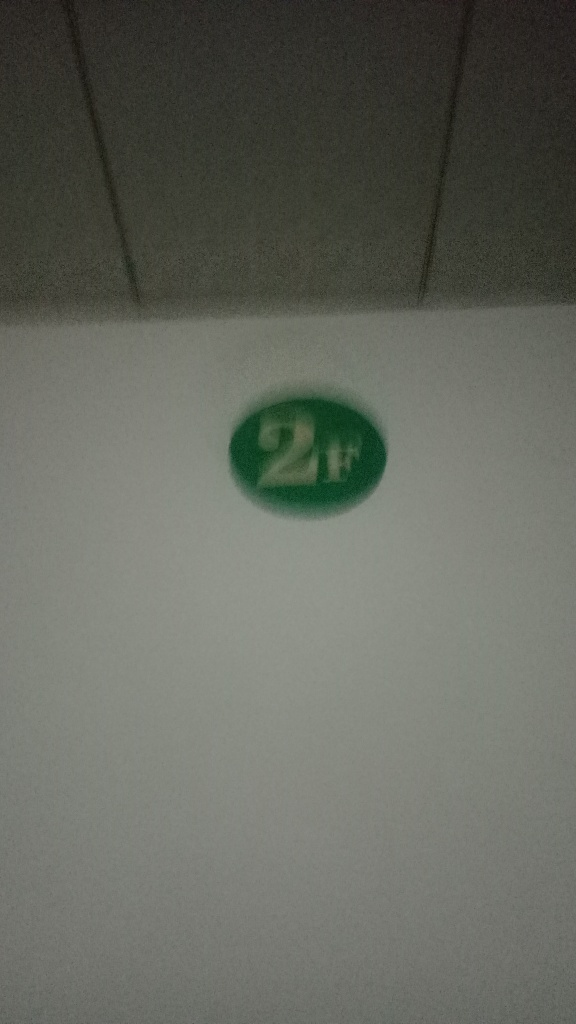Could this image be part of a larger series or set? It's possible that this image is part of a sequence or collection, especially if the object marked '2H' is used for categorization or identification. For instance, it could be a label within an educational setting, a workplace, or any scenario where such a coding system is pertinent. 